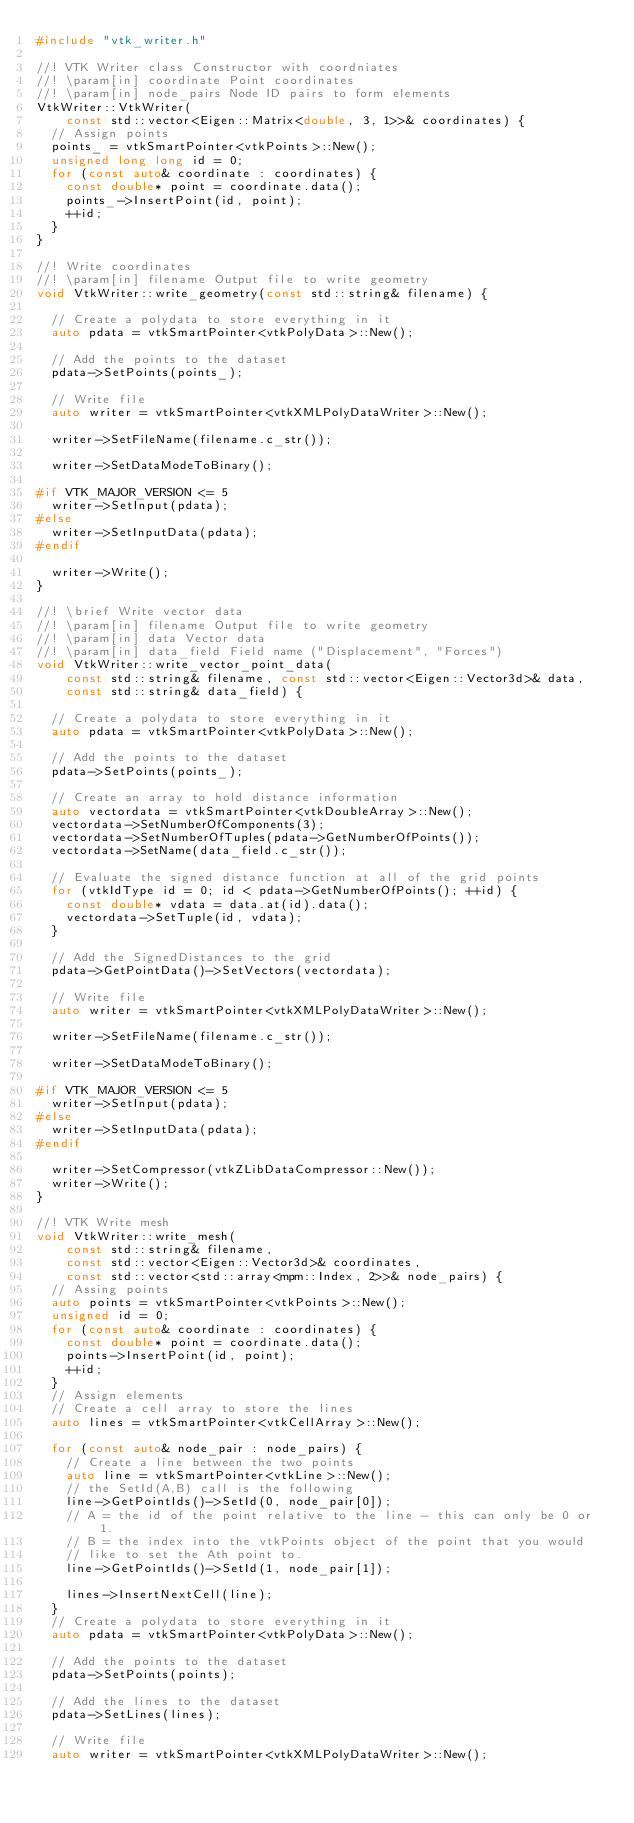<code> <loc_0><loc_0><loc_500><loc_500><_C++_>#include "vtk_writer.h"

//! VTK Writer class Constructor with coordniates
//! \param[in] coordinate Point coordinates
//! \param[in] node_pairs Node ID pairs to form elements
VtkWriter::VtkWriter(
    const std::vector<Eigen::Matrix<double, 3, 1>>& coordinates) {
  // Assign points
  points_ = vtkSmartPointer<vtkPoints>::New();
  unsigned long long id = 0;
  for (const auto& coordinate : coordinates) {
    const double* point = coordinate.data();
    points_->InsertPoint(id, point);
    ++id;
  }
}

//! Write coordinates
//! \param[in] filename Output file to write geometry
void VtkWriter::write_geometry(const std::string& filename) {

  // Create a polydata to store everything in it
  auto pdata = vtkSmartPointer<vtkPolyData>::New();

  // Add the points to the dataset
  pdata->SetPoints(points_);

  // Write file
  auto writer = vtkSmartPointer<vtkXMLPolyDataWriter>::New();

  writer->SetFileName(filename.c_str());

  writer->SetDataModeToBinary();

#if VTK_MAJOR_VERSION <= 5
  writer->SetInput(pdata);
#else
  writer->SetInputData(pdata);
#endif

  writer->Write();
}

//! \brief Write vector data
//! \param[in] filename Output file to write geometry
//! \param[in] data Vector data
//! \param[in] data_field Field name ("Displacement", "Forces")
void VtkWriter::write_vector_point_data(
    const std::string& filename, const std::vector<Eigen::Vector3d>& data,
    const std::string& data_field) {

  // Create a polydata to store everything in it
  auto pdata = vtkSmartPointer<vtkPolyData>::New();

  // Add the points to the dataset
  pdata->SetPoints(points_);

  // Create an array to hold distance information
  auto vectordata = vtkSmartPointer<vtkDoubleArray>::New();
  vectordata->SetNumberOfComponents(3);
  vectordata->SetNumberOfTuples(pdata->GetNumberOfPoints());
  vectordata->SetName(data_field.c_str());

  // Evaluate the signed distance function at all of the grid points
  for (vtkIdType id = 0; id < pdata->GetNumberOfPoints(); ++id) {
    const double* vdata = data.at(id).data();
    vectordata->SetTuple(id, vdata);
  }

  // Add the SignedDistances to the grid
  pdata->GetPointData()->SetVectors(vectordata);

  // Write file
  auto writer = vtkSmartPointer<vtkXMLPolyDataWriter>::New();

  writer->SetFileName(filename.c_str());

  writer->SetDataModeToBinary();

#if VTK_MAJOR_VERSION <= 5
  writer->SetInput(pdata);
#else
  writer->SetInputData(pdata);
#endif

  writer->SetCompressor(vtkZLibDataCompressor::New());
  writer->Write();
}

//! VTK Write mesh
void VtkWriter::write_mesh(
    const std::string& filename,
    const std::vector<Eigen::Vector3d>& coordinates,
    const std::vector<std::array<mpm::Index, 2>>& node_pairs) {
  // Assing points
  auto points = vtkSmartPointer<vtkPoints>::New();
  unsigned id = 0;
  for (const auto& coordinate : coordinates) {
    const double* point = coordinate.data();
    points->InsertPoint(id, point);
    ++id;
  }
  // Assign elements
  // Create a cell array to store the lines
  auto lines = vtkSmartPointer<vtkCellArray>::New();

  for (const auto& node_pair : node_pairs) {
    // Create a line between the two points
    auto line = vtkSmartPointer<vtkLine>::New();
    // the SetId(A,B) call is the following
    line->GetPointIds()->SetId(0, node_pair[0]);
    // A = the id of the point relative to the line - this can only be 0 or 1.
    // B = the index into the vtkPoints object of the point that you would
    // like to set the Ath point to.
    line->GetPointIds()->SetId(1, node_pair[1]);

    lines->InsertNextCell(line);
  }
  // Create a polydata to store everything in it
  auto pdata = vtkSmartPointer<vtkPolyData>::New();

  // Add the points to the dataset
  pdata->SetPoints(points);

  // Add the lines to the dataset
  pdata->SetLines(lines);

  // Write file
  auto writer = vtkSmartPointer<vtkXMLPolyDataWriter>::New();
</code> 